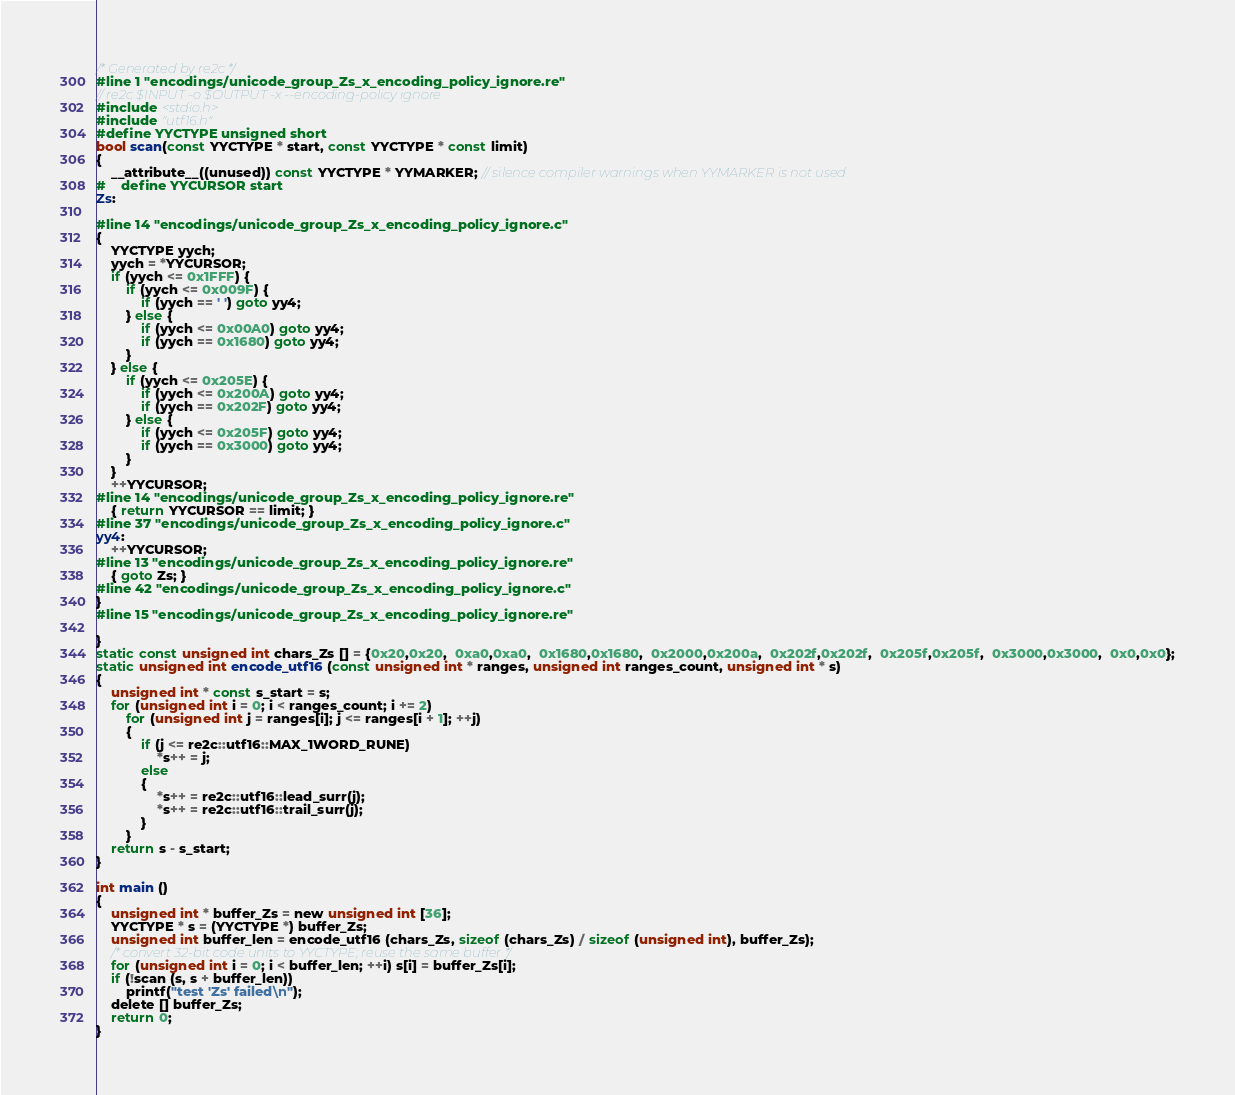<code> <loc_0><loc_0><loc_500><loc_500><_C_>/* Generated by re2c */
#line 1 "encodings/unicode_group_Zs_x_encoding_policy_ignore.re"
// re2c $INPUT -o $OUTPUT -x --encoding-policy ignore
#include <stdio.h>
#include "utf16.h"
#define YYCTYPE unsigned short
bool scan(const YYCTYPE * start, const YYCTYPE * const limit)
{
	__attribute__((unused)) const YYCTYPE * YYMARKER; // silence compiler warnings when YYMARKER is not used
#	define YYCURSOR start
Zs:
	
#line 14 "encodings/unicode_group_Zs_x_encoding_policy_ignore.c"
{
	YYCTYPE yych;
	yych = *YYCURSOR;
	if (yych <= 0x1FFF) {
		if (yych <= 0x009F) {
			if (yych == ' ') goto yy4;
		} else {
			if (yych <= 0x00A0) goto yy4;
			if (yych == 0x1680) goto yy4;
		}
	} else {
		if (yych <= 0x205E) {
			if (yych <= 0x200A) goto yy4;
			if (yych == 0x202F) goto yy4;
		} else {
			if (yych <= 0x205F) goto yy4;
			if (yych == 0x3000) goto yy4;
		}
	}
	++YYCURSOR;
#line 14 "encodings/unicode_group_Zs_x_encoding_policy_ignore.re"
	{ return YYCURSOR == limit; }
#line 37 "encodings/unicode_group_Zs_x_encoding_policy_ignore.c"
yy4:
	++YYCURSOR;
#line 13 "encodings/unicode_group_Zs_x_encoding_policy_ignore.re"
	{ goto Zs; }
#line 42 "encodings/unicode_group_Zs_x_encoding_policy_ignore.c"
}
#line 15 "encodings/unicode_group_Zs_x_encoding_policy_ignore.re"

}
static const unsigned int chars_Zs [] = {0x20,0x20,  0xa0,0xa0,  0x1680,0x1680,  0x2000,0x200a,  0x202f,0x202f,  0x205f,0x205f,  0x3000,0x3000,  0x0,0x0};
static unsigned int encode_utf16 (const unsigned int * ranges, unsigned int ranges_count, unsigned int * s)
{
	unsigned int * const s_start = s;
	for (unsigned int i = 0; i < ranges_count; i += 2)
		for (unsigned int j = ranges[i]; j <= ranges[i + 1]; ++j)
		{
			if (j <= re2c::utf16::MAX_1WORD_RUNE)
				*s++ = j;
			else
			{
				*s++ = re2c::utf16::lead_surr(j);
				*s++ = re2c::utf16::trail_surr(j);
			}
		}
	return s - s_start;
}

int main ()
{
	unsigned int * buffer_Zs = new unsigned int [36];
	YYCTYPE * s = (YYCTYPE *) buffer_Zs;
	unsigned int buffer_len = encode_utf16 (chars_Zs, sizeof (chars_Zs) / sizeof (unsigned int), buffer_Zs);
	/* convert 32-bit code units to YYCTYPE; reuse the same buffer */
	for (unsigned int i = 0; i < buffer_len; ++i) s[i] = buffer_Zs[i];
	if (!scan (s, s + buffer_len))
		printf("test 'Zs' failed\n");
	delete [] buffer_Zs;
	return 0;
}
</code> 